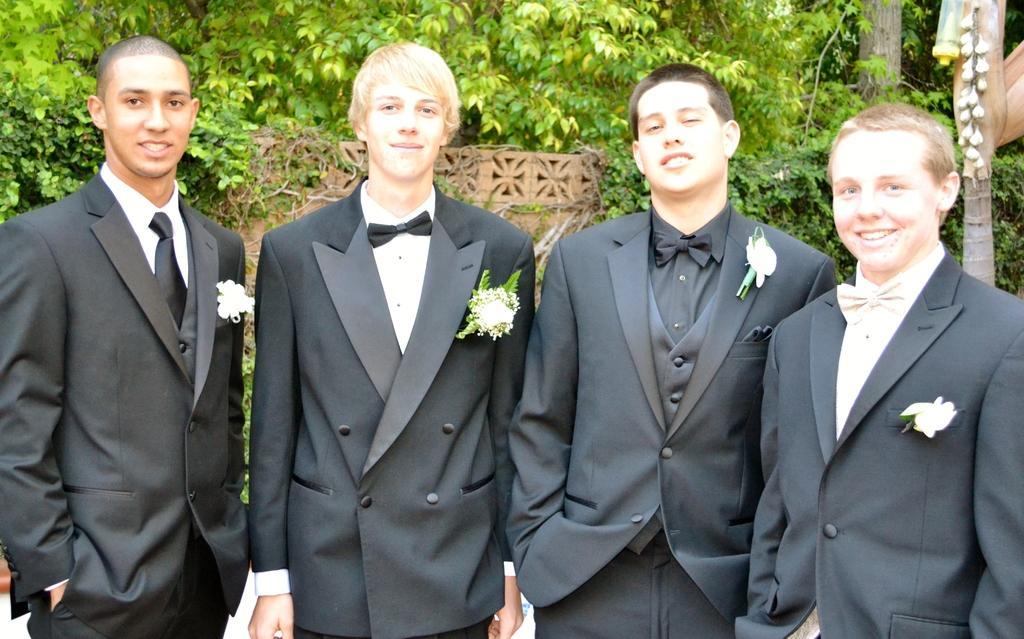How would you summarize this image in a sentence or two? Here we can see four men standing. In the background there are trees,plants,wall and an object on the right. 